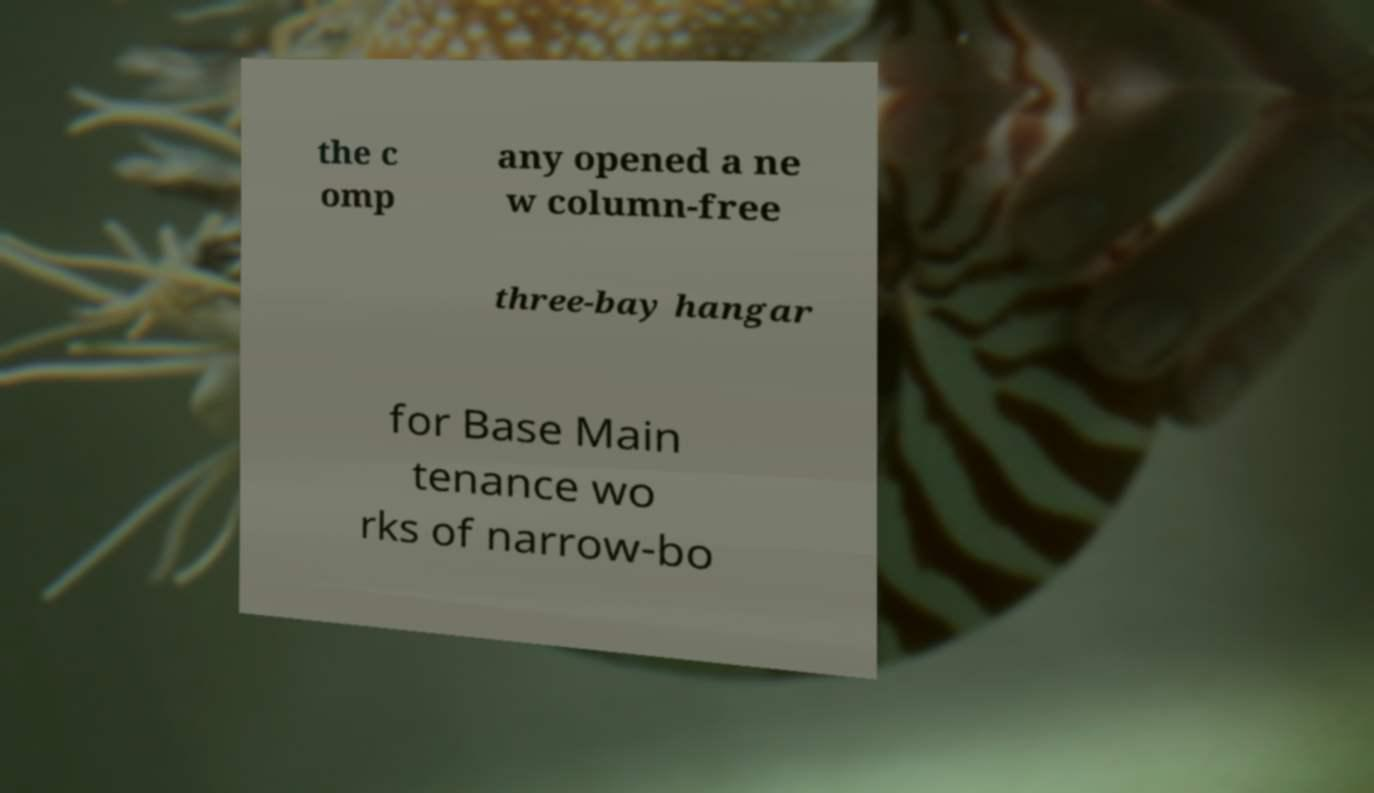Can you read and provide the text displayed in the image?This photo seems to have some interesting text. Can you extract and type it out for me? the c omp any opened a ne w column-free three-bay hangar for Base Main tenance wo rks of narrow-bo 